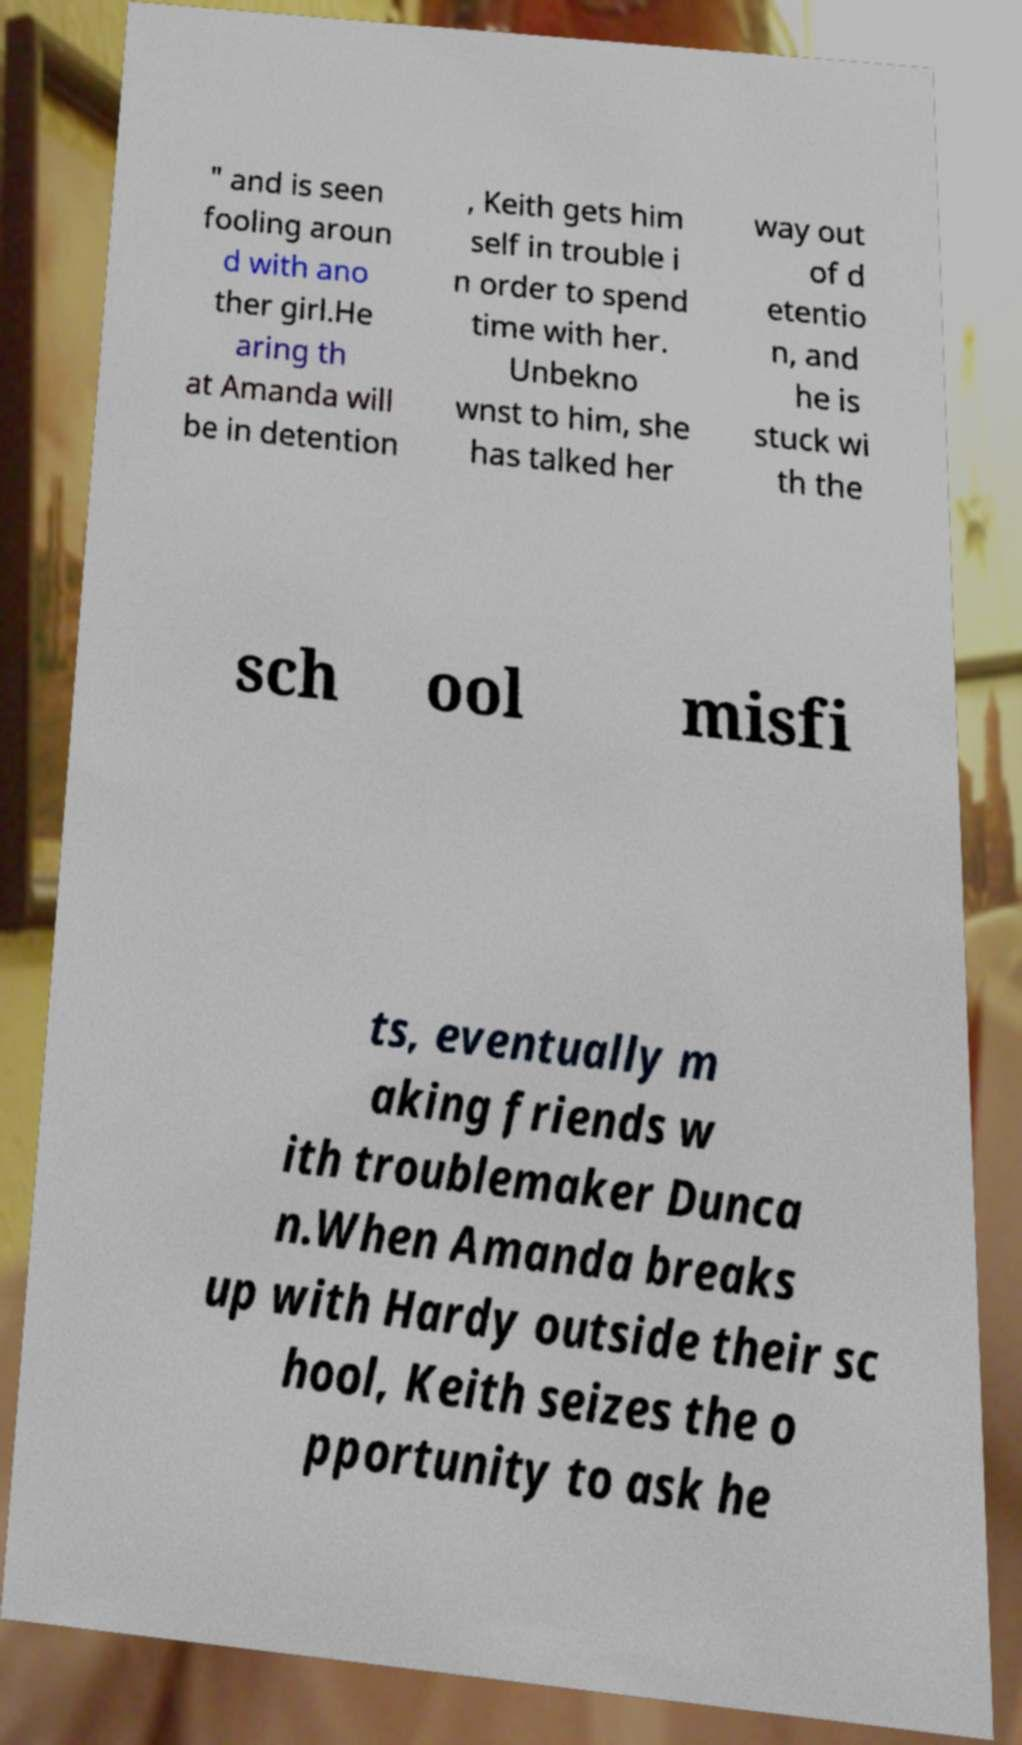I need the written content from this picture converted into text. Can you do that? " and is seen fooling aroun d with ano ther girl.He aring th at Amanda will be in detention , Keith gets him self in trouble i n order to spend time with her. Unbekno wnst to him, she has talked her way out of d etentio n, and he is stuck wi th the sch ool misfi ts, eventually m aking friends w ith troublemaker Dunca n.When Amanda breaks up with Hardy outside their sc hool, Keith seizes the o pportunity to ask he 